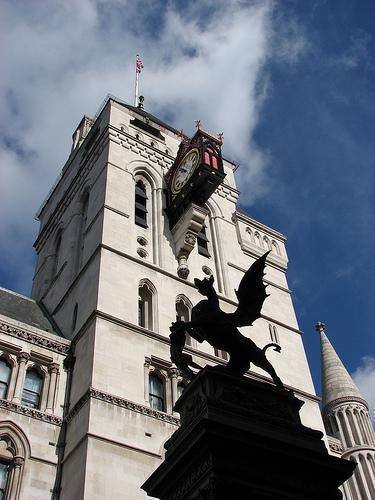How many clocks are shown?
Give a very brief answer. 1. How many big winged animals are shown?
Give a very brief answer. 1. 